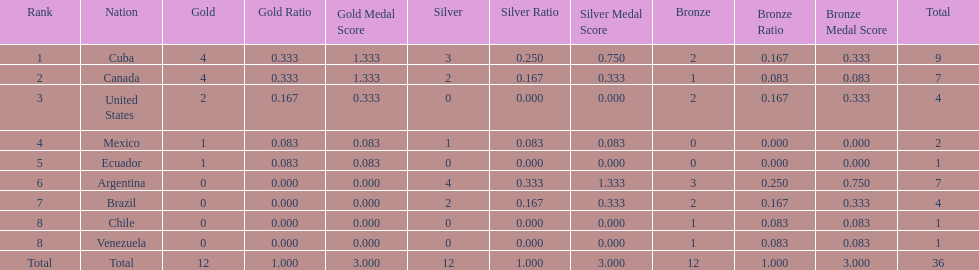Which is the only nation to win a gold medal and nothing else? Ecuador. 